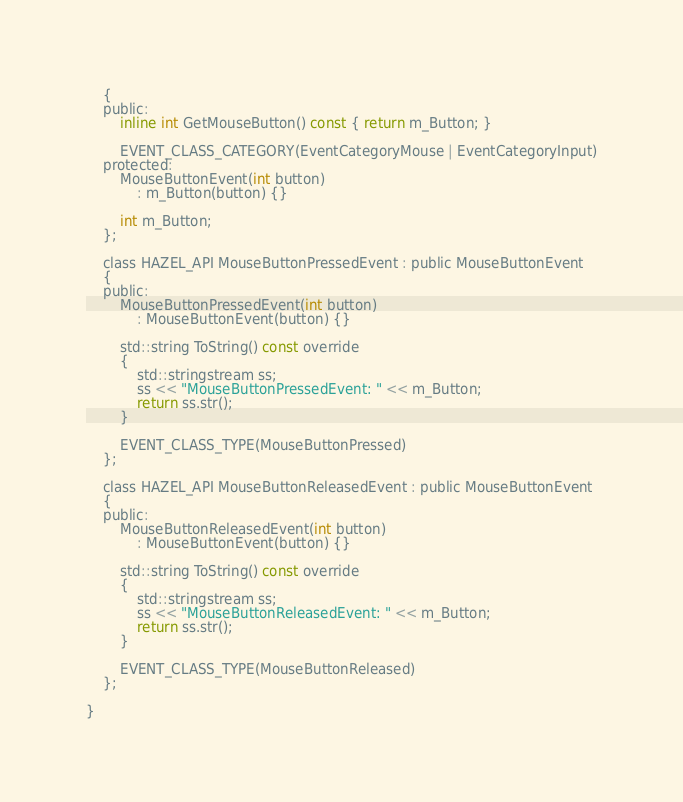Convert code to text. <code><loc_0><loc_0><loc_500><loc_500><_C_>	{
	public:
		inline int GetMouseButton() const { return m_Button; }

		EVENT_CLASS_CATEGORY(EventCategoryMouse | EventCategoryInput)
	protected:
		MouseButtonEvent(int button)
			: m_Button(button) {}

		int m_Button;
	};

	class HAZEL_API MouseButtonPressedEvent : public MouseButtonEvent
	{
	public:
		MouseButtonPressedEvent(int button)
			: MouseButtonEvent(button) {}

		std::string ToString() const override
		{
			std::stringstream ss;
			ss << "MouseButtonPressedEvent: " << m_Button;
			return ss.str();
		}

		EVENT_CLASS_TYPE(MouseButtonPressed)
	};

	class HAZEL_API MouseButtonReleasedEvent : public MouseButtonEvent
	{
	public:
		MouseButtonReleasedEvent(int button)
			: MouseButtonEvent(button) {}

		std::string ToString() const override
		{
			std::stringstream ss;
			ss << "MouseButtonReleasedEvent: " << m_Button;
			return ss.str();
		}

		EVENT_CLASS_TYPE(MouseButtonReleased)
	};

}</code> 